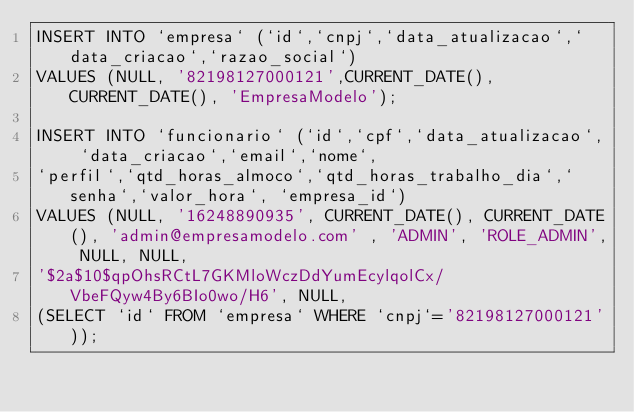<code> <loc_0><loc_0><loc_500><loc_500><_SQL_>INSERT INTO `empresa` (`id`,`cnpj`,`data_atualizacao`,`data_criacao`,`razao_social`)
VALUES (NULL, '82198127000121',CURRENT_DATE(), CURRENT_DATE(), 'EmpresaModelo');

INSERT INTO `funcionario` (`id`,`cpf`,`data_atualizacao`, `data_criacao`,`email`,`nome`,
`perfil`,`qtd_horas_almoco`,`qtd_horas_trabalho_dia`,`senha`,`valor_hora`, `empresa_id`)
VALUES (NULL, '16248890935', CURRENT_DATE(), CURRENT_DATE(), 'admin@empresamodelo.com' , 'ADMIN', 'ROLE_ADMIN', NULL, NULL,
'$2a$10$qpOhsRCtL7GKMloWczDdYumEcylqolCx/VbeFQyw4By6BIo0wo/H6', NULL,
(SELECT `id` FROM `empresa` WHERE `cnpj`='82198127000121'));</code> 